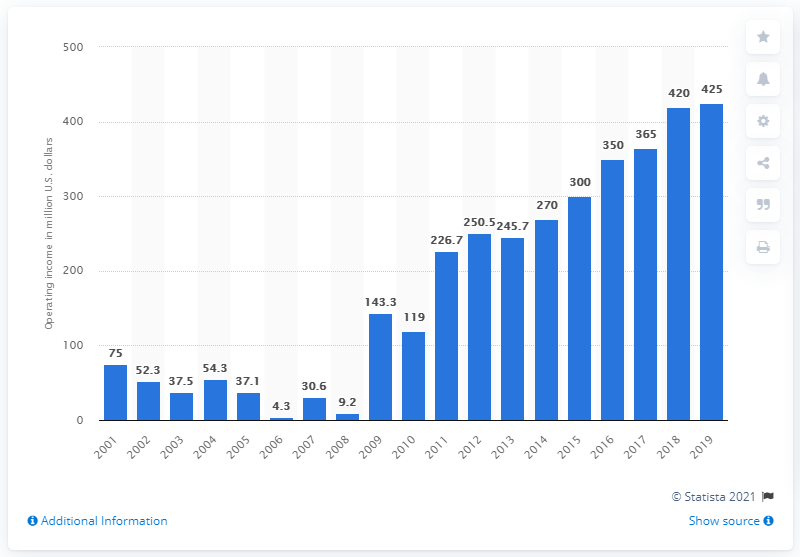Point out several critical features in this image. The operating income of the Dallas Cowboys for the 2019 season was 425. 